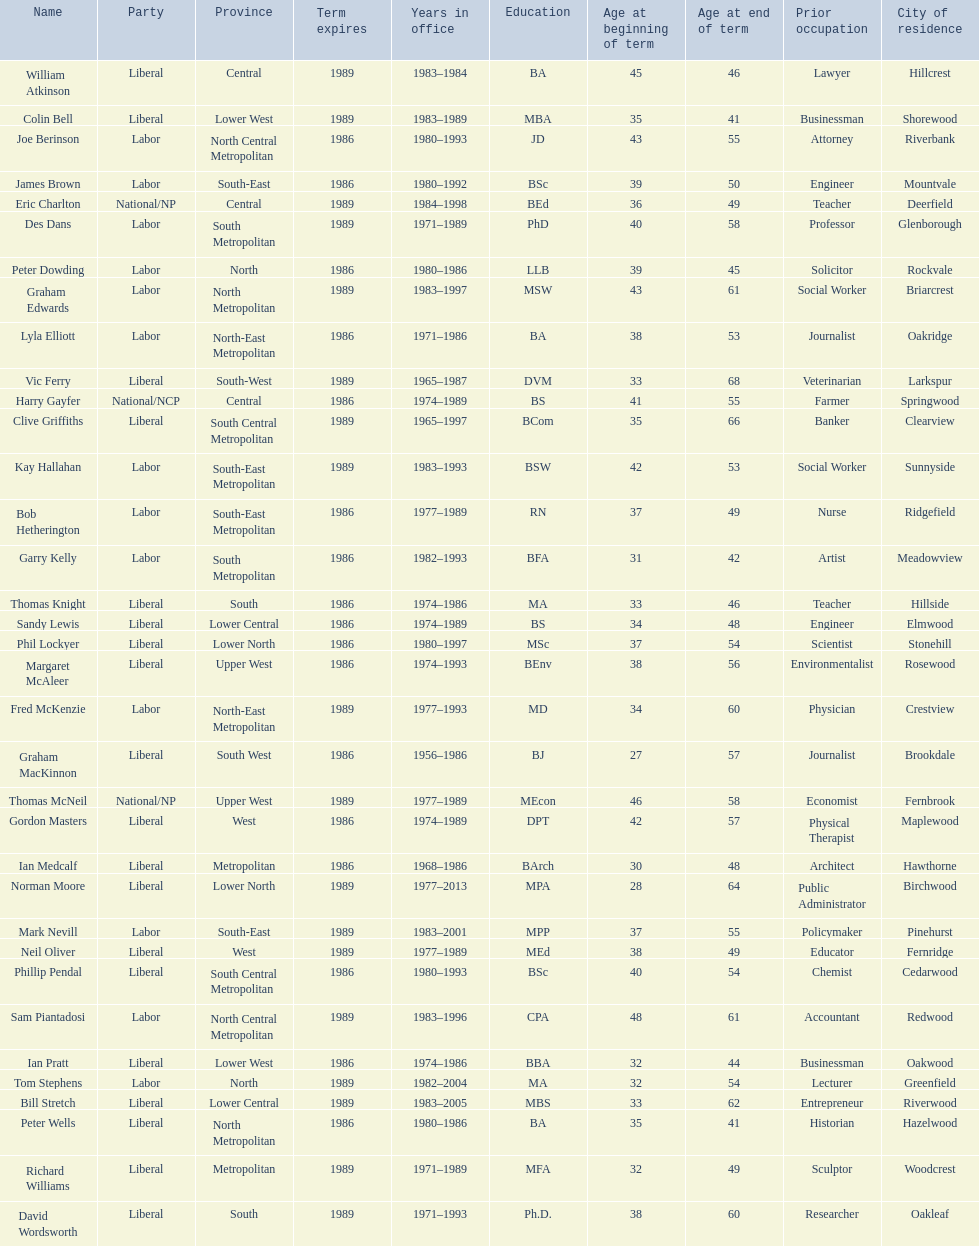Which party has the most membership? Liberal. 